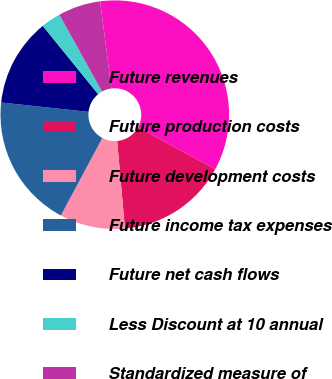<chart> <loc_0><loc_0><loc_500><loc_500><pie_chart><fcel>Future revenues<fcel>Future production costs<fcel>Future development costs<fcel>Future income tax expenses<fcel>Future net cash flows<fcel>Less Discount at 10 annual<fcel>Standardized measure of<nl><fcel>34.97%<fcel>15.66%<fcel>9.23%<fcel>18.88%<fcel>12.45%<fcel>2.79%<fcel>6.01%<nl></chart> 